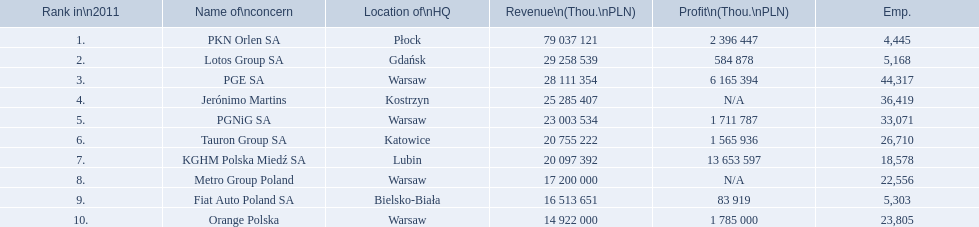Would you be able to parse every entry in this table? {'header': ['Rank in\\n2011', 'Name of\\nconcern', 'Location of\\nHQ', 'Revenue\\n(Thou.\\nPLN)', 'Profit\\n(Thou.\\nPLN)', 'Emp.'], 'rows': [['1.', 'PKN Orlen SA', 'Płock', '79 037 121', '2 396 447', '4,445'], ['2.', 'Lotos Group SA', 'Gdańsk', '29 258 539', '584 878', '5,168'], ['3.', 'PGE SA', 'Warsaw', '28 111 354', '6 165 394', '44,317'], ['4.', 'Jerónimo Martins', 'Kostrzyn', '25 285 407', 'N/A', '36,419'], ['5.', 'PGNiG SA', 'Warsaw', '23 003 534', '1 711 787', '33,071'], ['6.', 'Tauron Group SA', 'Katowice', '20 755 222', '1 565 936', '26,710'], ['7.', 'KGHM Polska Miedź SA', 'Lubin', '20 097 392', '13 653 597', '18,578'], ['8.', 'Metro Group Poland', 'Warsaw', '17 200 000', 'N/A', '22,556'], ['9.', 'Fiat Auto Poland SA', 'Bielsko-Biała', '16 513 651', '83 919', '5,303'], ['10.', 'Orange Polska', 'Warsaw', '14 922 000', '1 785 000', '23,805']]} What companies are listed? PKN Orlen SA, Lotos Group SA, PGE SA, Jerónimo Martins, PGNiG SA, Tauron Group SA, KGHM Polska Miedź SA, Metro Group Poland, Fiat Auto Poland SA, Orange Polska. What are the company's revenues? 79 037 121, 29 258 539, 28 111 354, 25 285 407, 23 003 534, 20 755 222, 20 097 392, 17 200 000, 16 513 651, 14 922 000. Which company has the greatest revenue? PKN Orlen SA. 